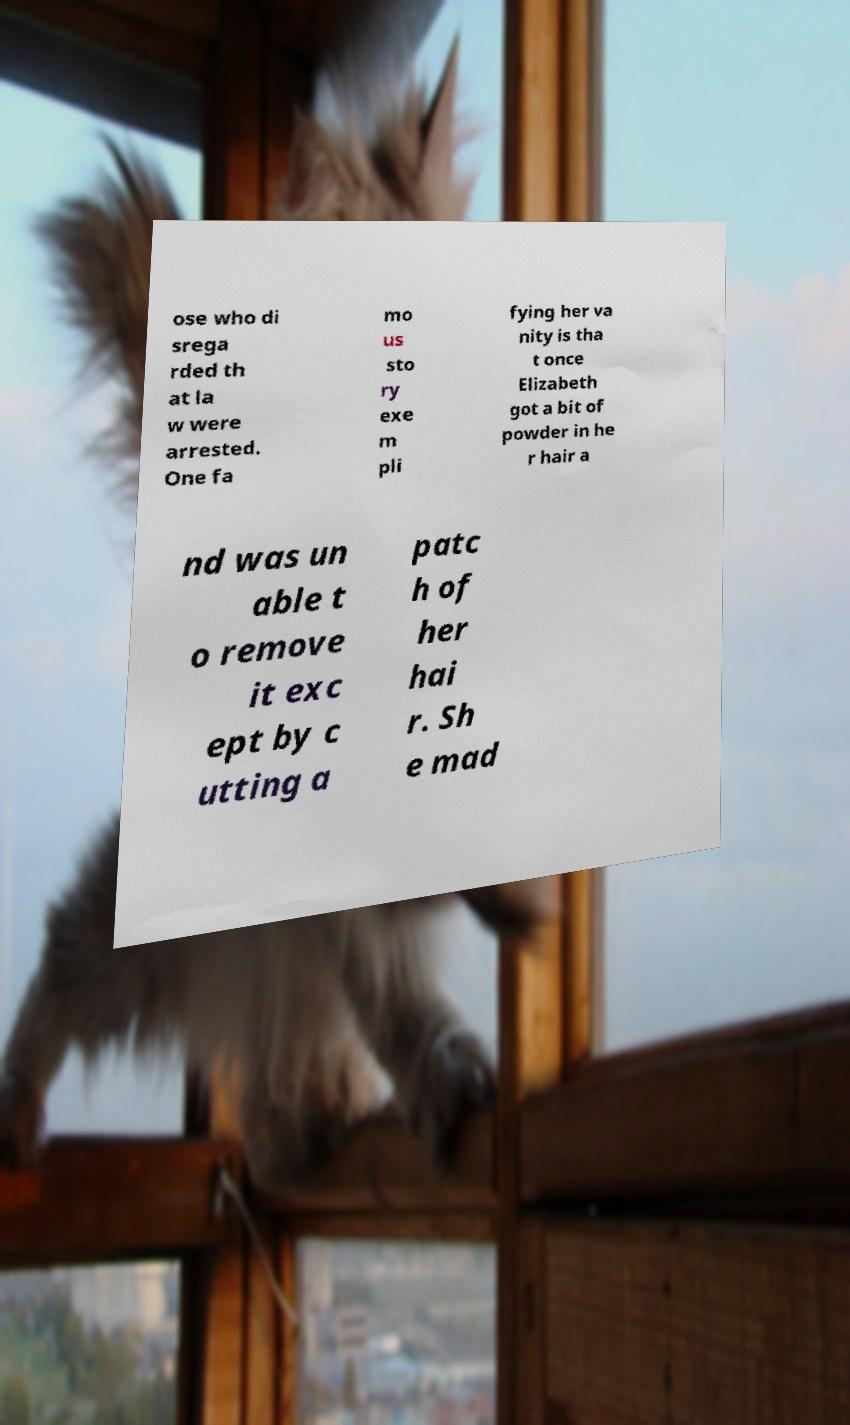What messages or text are displayed in this image? I need them in a readable, typed format. ose who di srega rded th at la w were arrested. One fa mo us sto ry exe m pli fying her va nity is tha t once Elizabeth got a bit of powder in he r hair a nd was un able t o remove it exc ept by c utting a patc h of her hai r. Sh e mad 